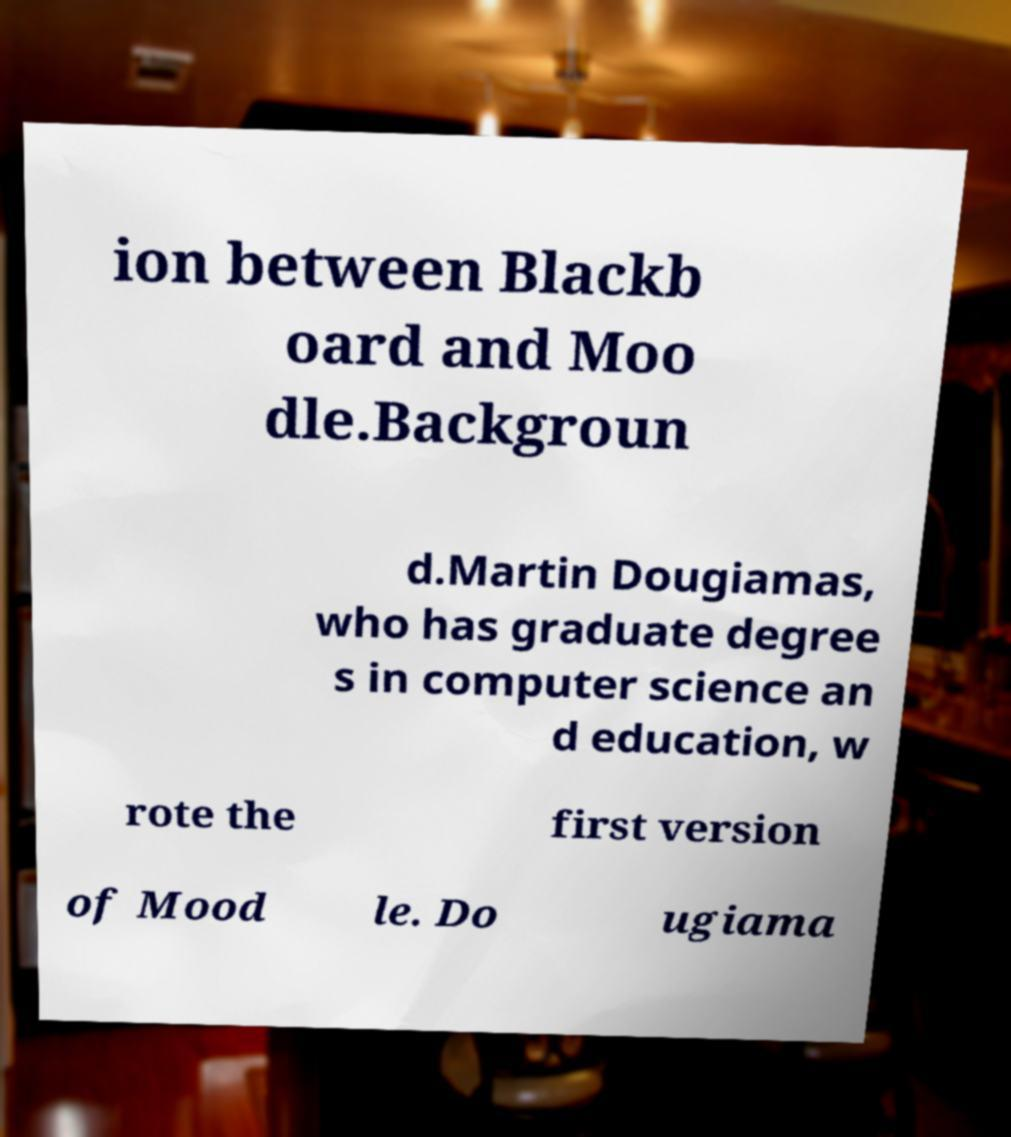I need the written content from this picture converted into text. Can you do that? ion between Blackb oard and Moo dle.Backgroun d.Martin Dougiamas, who has graduate degree s in computer science an d education, w rote the first version of Mood le. Do ugiama 